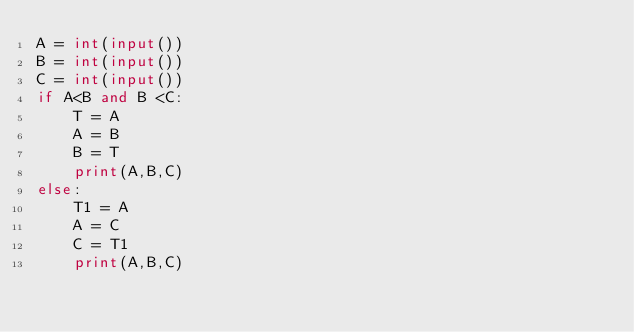Convert code to text. <code><loc_0><loc_0><loc_500><loc_500><_Python_>A = int(input())
B = int(input())
C = int(input())
if A<B and B <C:
    T = A
    A = B
    B = T
	print(A,B,C)
else:
    T1 = A
    A = C
    C = T1
    print(A,B,C)</code> 